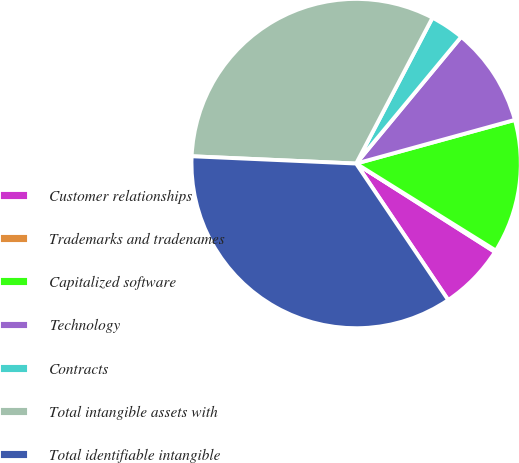Convert chart to OTSL. <chart><loc_0><loc_0><loc_500><loc_500><pie_chart><fcel>Customer relationships<fcel>Trademarks and tradenames<fcel>Capitalized software<fcel>Technology<fcel>Contracts<fcel>Total intangible assets with<fcel>Total identifiable intangible<nl><fcel>6.53%<fcel>0.16%<fcel>13.14%<fcel>9.71%<fcel>3.34%<fcel>31.97%<fcel>35.15%<nl></chart> 